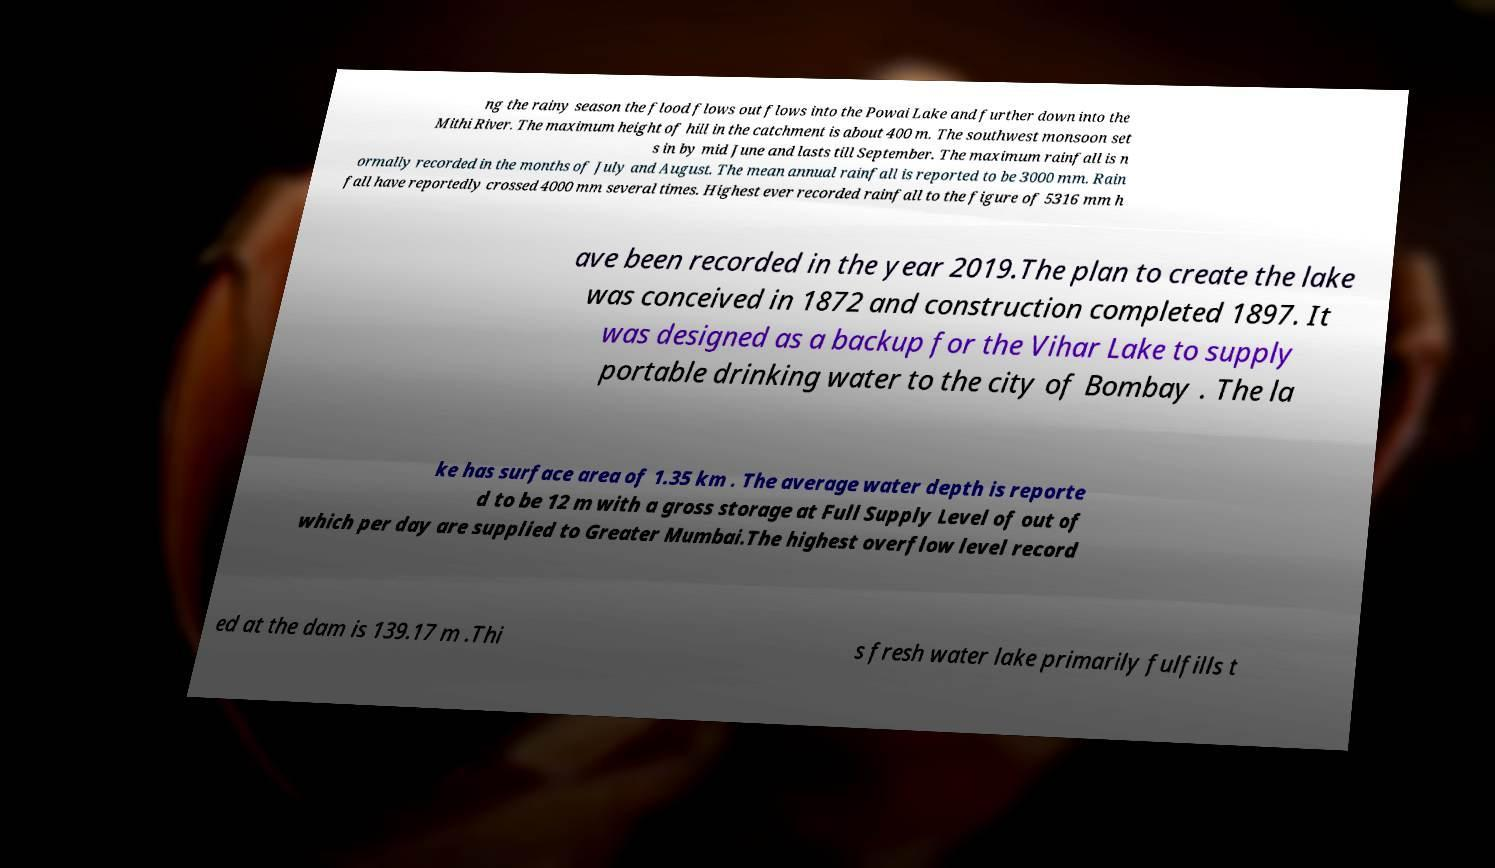I need the written content from this picture converted into text. Can you do that? ng the rainy season the flood flows out flows into the Powai Lake and further down into the Mithi River. The maximum height of hill in the catchment is about 400 m. The southwest monsoon set s in by mid June and lasts till September. The maximum rainfall is n ormally recorded in the months of July and August. The mean annual rainfall is reported to be 3000 mm. Rain fall have reportedly crossed 4000 mm several times. Highest ever recorded rainfall to the figure of 5316 mm h ave been recorded in the year 2019.The plan to create the lake was conceived in 1872 and construction completed 1897. It was designed as a backup for the Vihar Lake to supply portable drinking water to the city of Bombay . The la ke has surface area of 1.35 km . The average water depth is reporte d to be 12 m with a gross storage at Full Supply Level of out of which per day are supplied to Greater Mumbai.The highest overflow level record ed at the dam is 139.17 m .Thi s fresh water lake primarily fulfills t 